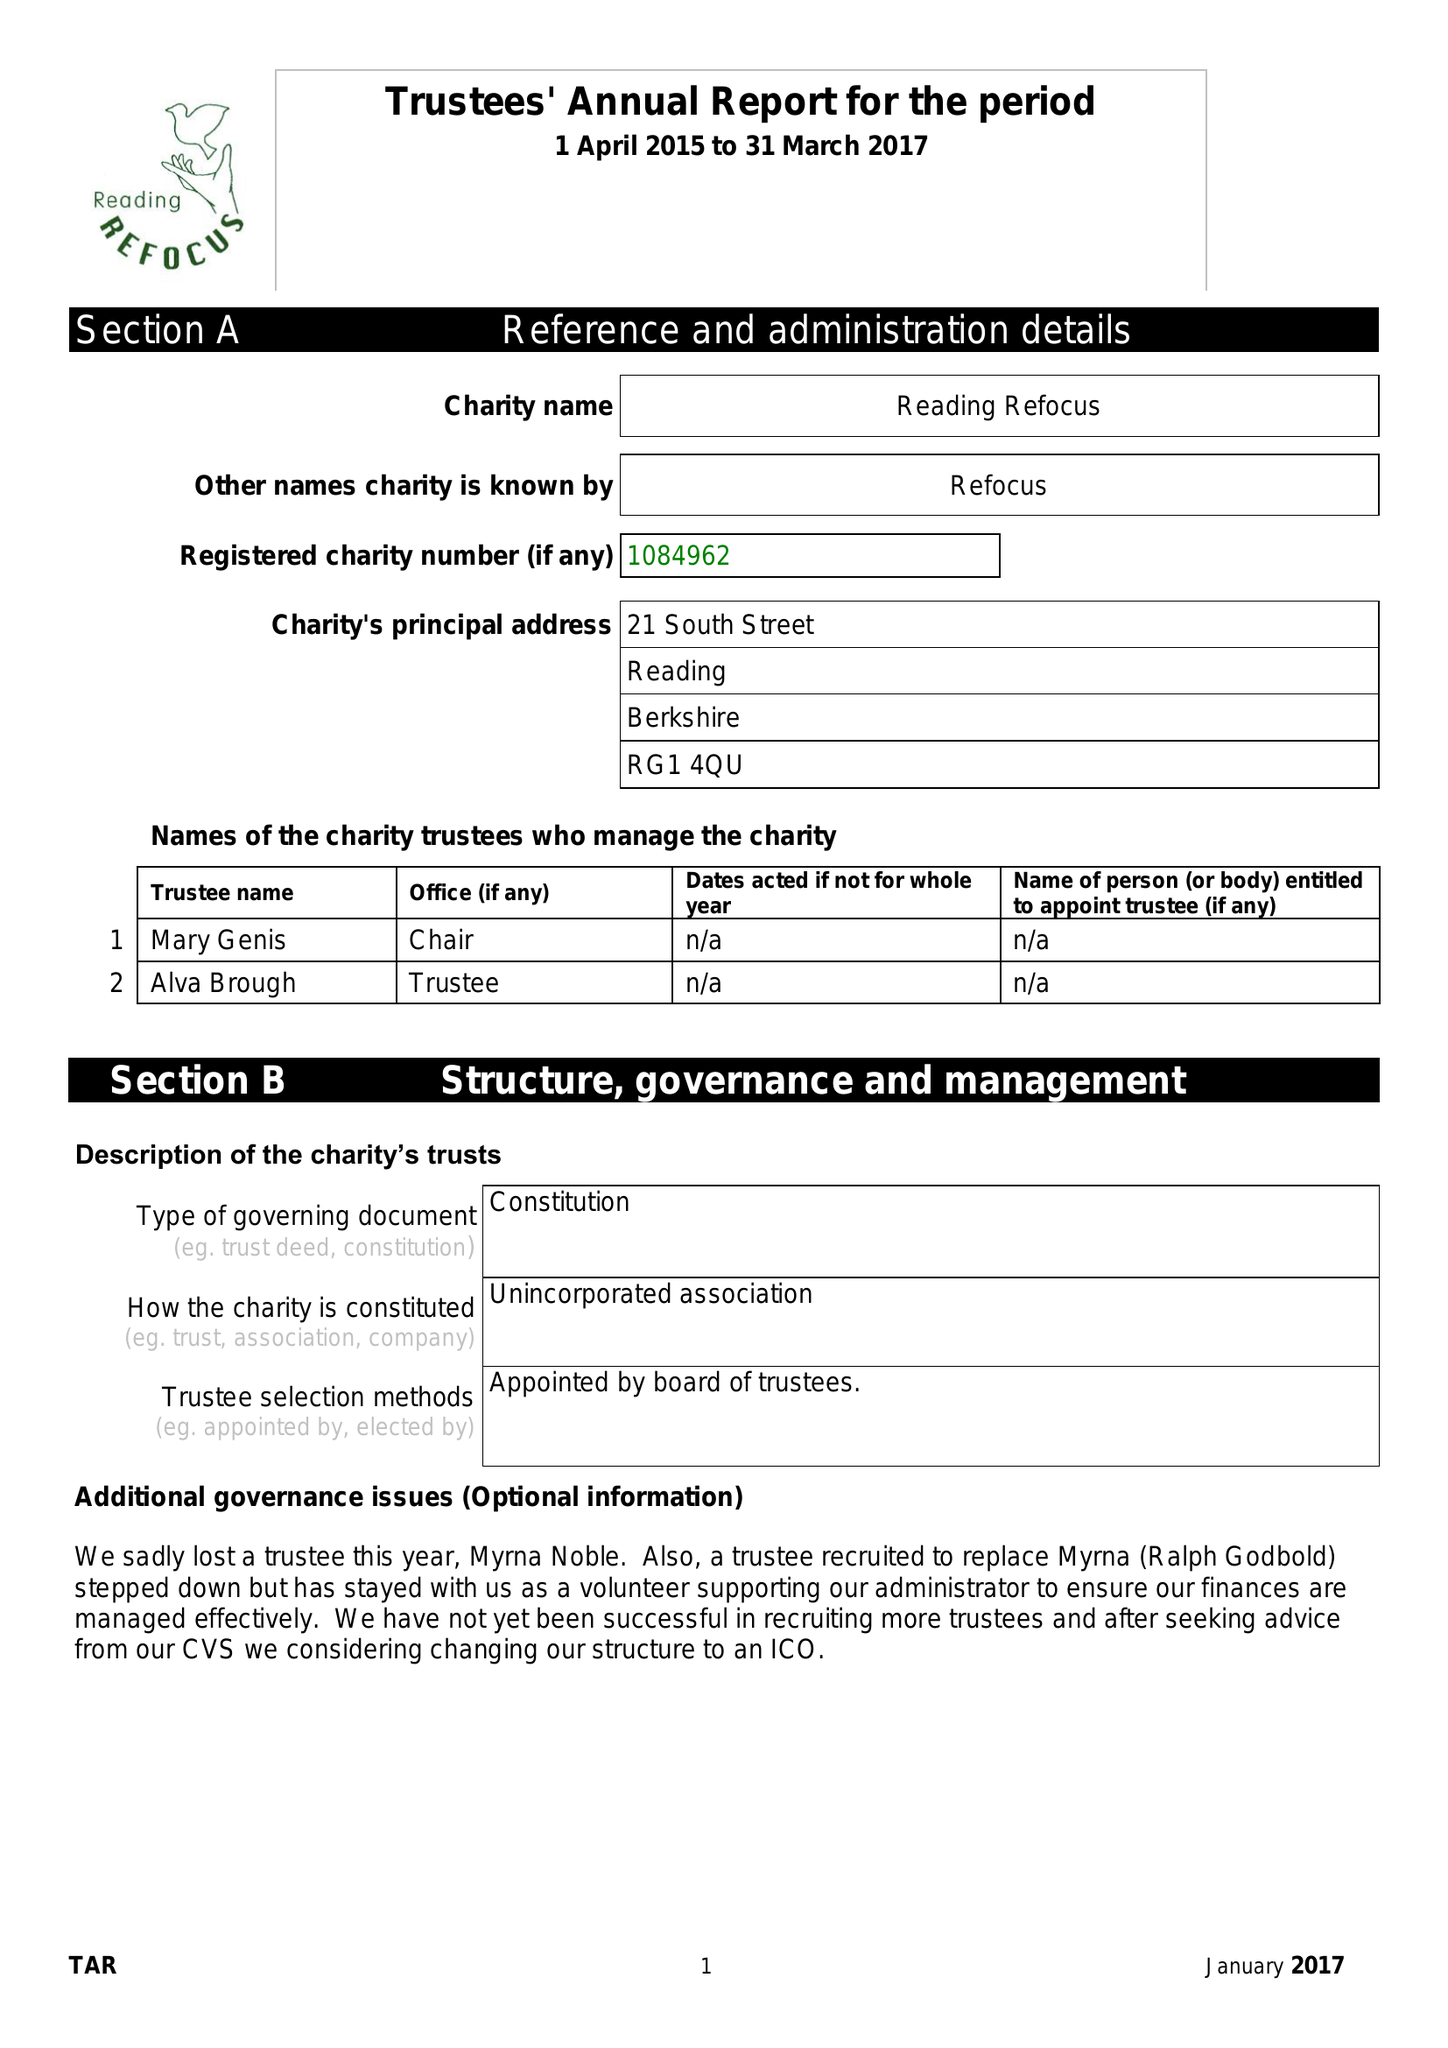What is the value for the address__postcode?
Answer the question using a single word or phrase. RG1 4QU 